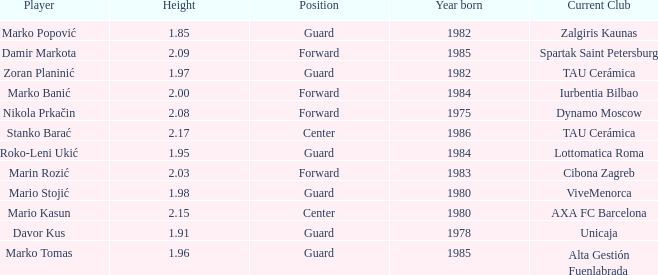What is the height of the player who currently plays for Alta Gestión Fuenlabrada? 1.96. Write the full table. {'header': ['Player', 'Height', 'Position', 'Year born', 'Current Club'], 'rows': [['Marko Popović', '1.85', 'Guard', '1982', 'Zalgiris Kaunas'], ['Damir Markota', '2.09', 'Forward', '1985', 'Spartak Saint Petersburg'], ['Zoran Planinić', '1.97', 'Guard', '1982', 'TAU Cerámica'], ['Marko Banić', '2.00', 'Forward', '1984', 'Iurbentia Bilbao'], ['Nikola Prkačin', '2.08', 'Forward', '1975', 'Dynamo Moscow'], ['Stanko Barać', '2.17', 'Center', '1986', 'TAU Cerámica'], ['Roko-Leni Ukić', '1.95', 'Guard', '1984', 'Lottomatica Roma'], ['Marin Rozić', '2.03', 'Forward', '1983', 'Cibona Zagreb'], ['Mario Stojić', '1.98', 'Guard', '1980', 'ViveMenorca'], ['Mario Kasun', '2.15', 'Center', '1980', 'AXA FC Barcelona'], ['Davor Kus', '1.91', 'Guard', '1978', 'Unicaja'], ['Marko Tomas', '1.96', 'Guard', '1985', 'Alta Gestión Fuenlabrada']]} 